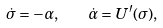<formula> <loc_0><loc_0><loc_500><loc_500>\dot { \sigma } = - \alpha , \quad \dot { \alpha } = U ^ { \prime } ( \sigma ) ,</formula> 